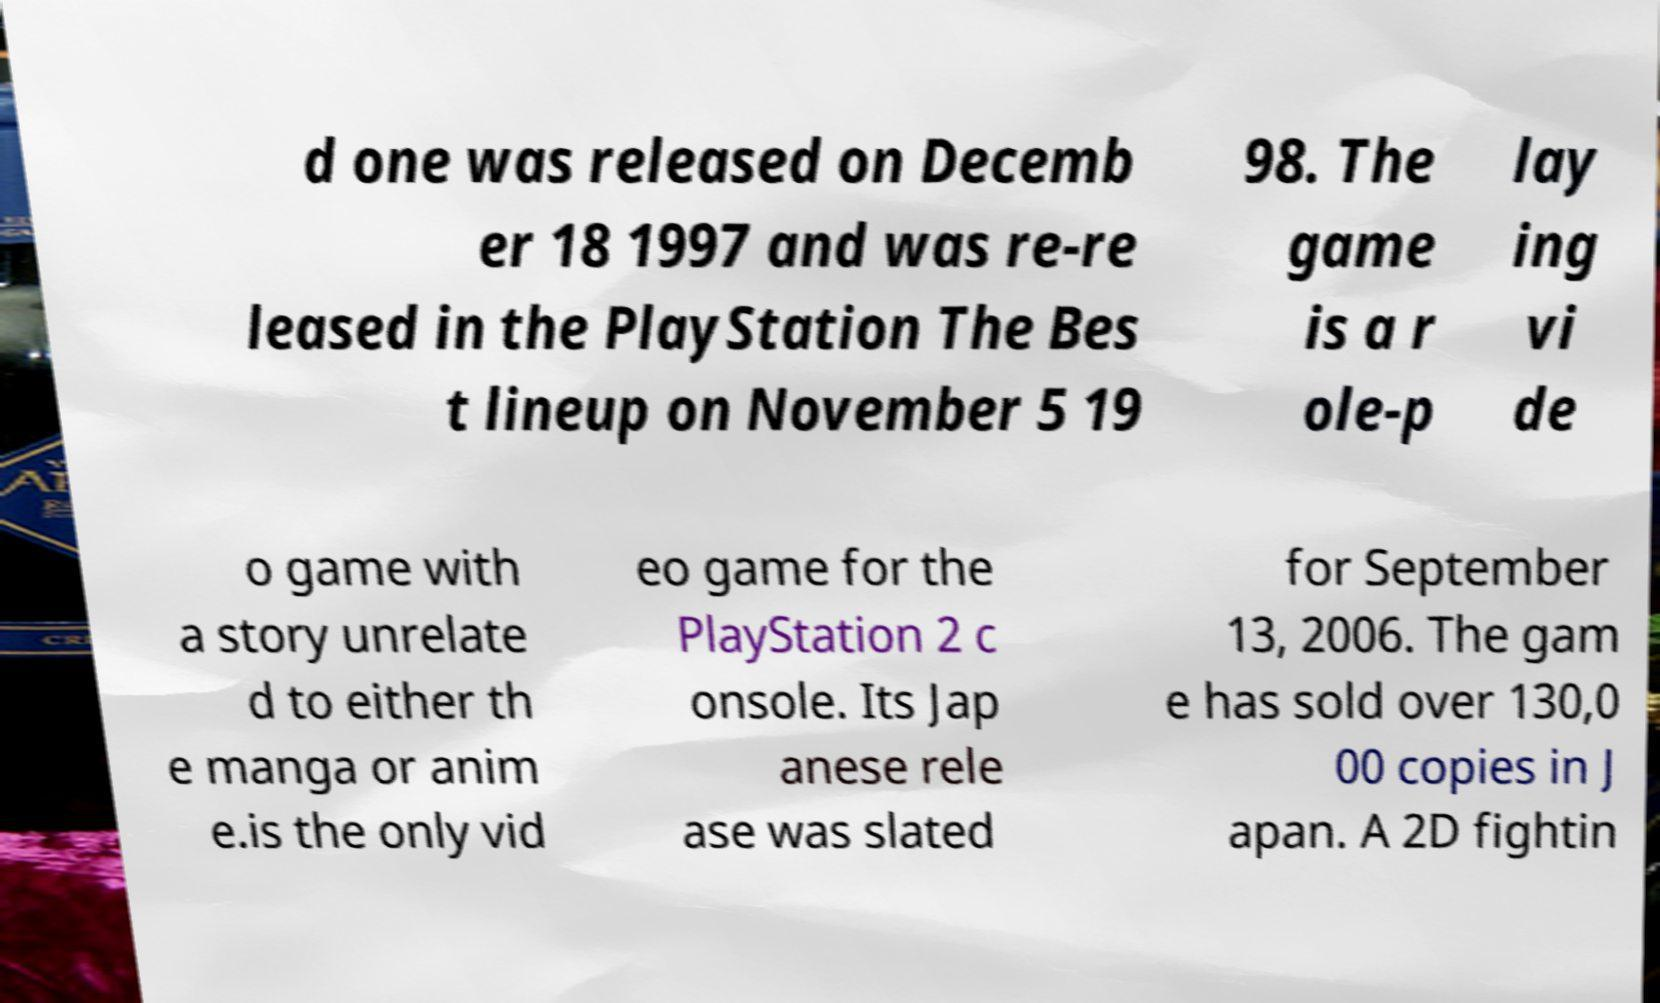Can you read and provide the text displayed in the image?This photo seems to have some interesting text. Can you extract and type it out for me? d one was released on Decemb er 18 1997 and was re-re leased in the PlayStation The Bes t lineup on November 5 19 98. The game is a r ole-p lay ing vi de o game with a story unrelate d to either th e manga or anim e.is the only vid eo game for the PlayStation 2 c onsole. Its Jap anese rele ase was slated for September 13, 2006. The gam e has sold over 130,0 00 copies in J apan. A 2D fightin 